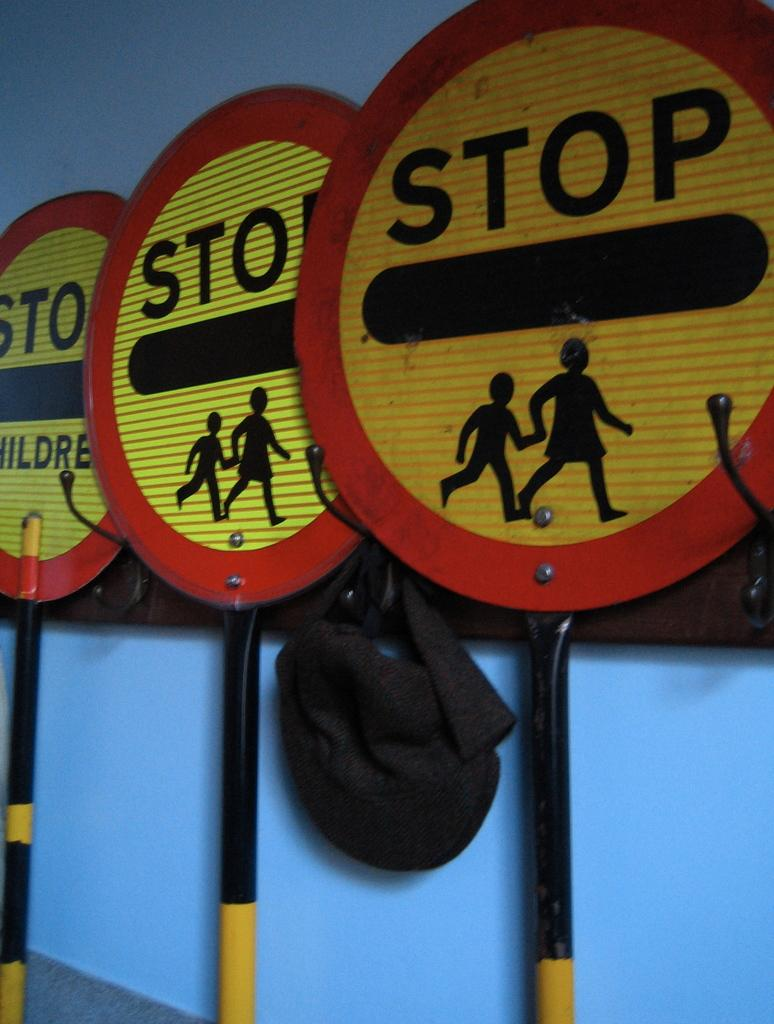<image>
Give a short and clear explanation of the subsequent image. Three signs with a mother holding her child telling someone to stop. 